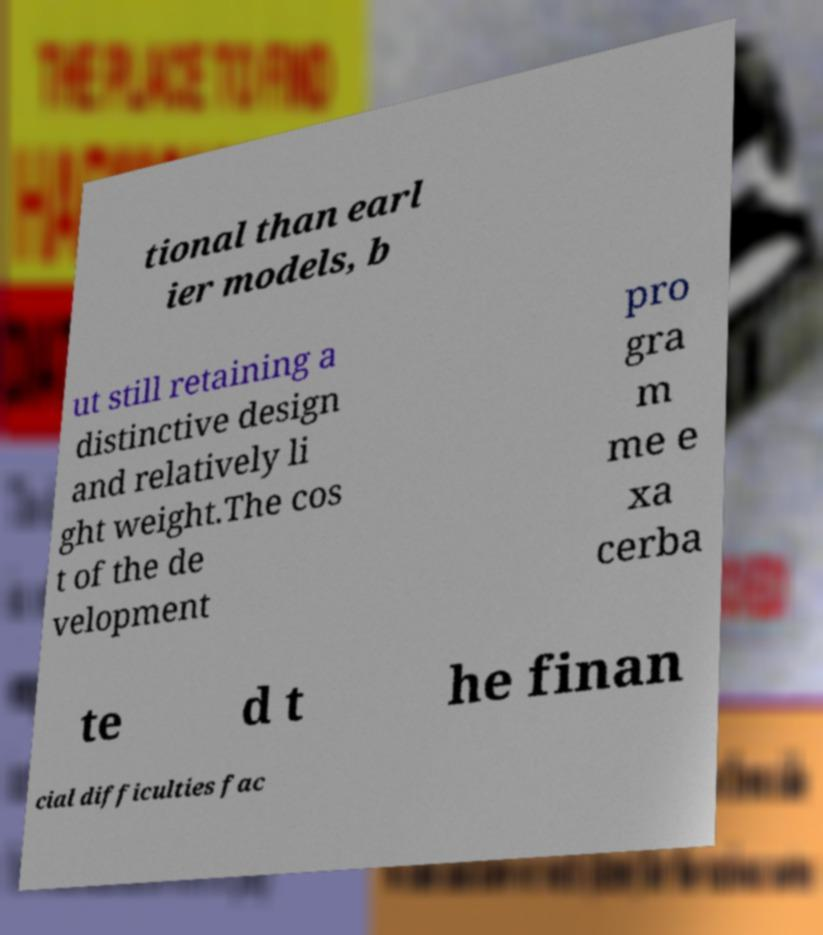What messages or text are displayed in this image? I need them in a readable, typed format. tional than earl ier models, b ut still retaining a distinctive design and relatively li ght weight.The cos t of the de velopment pro gra m me e xa cerba te d t he finan cial difficulties fac 